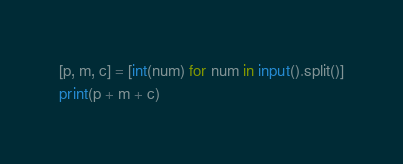<code> <loc_0><loc_0><loc_500><loc_500><_Python_>[p, m, c] = [int(num) for num in input().split()]
print(p + m + c)</code> 